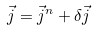Convert formula to latex. <formula><loc_0><loc_0><loc_500><loc_500>\vec { j } = \vec { j } ^ { n } + \delta \vec { j }</formula> 